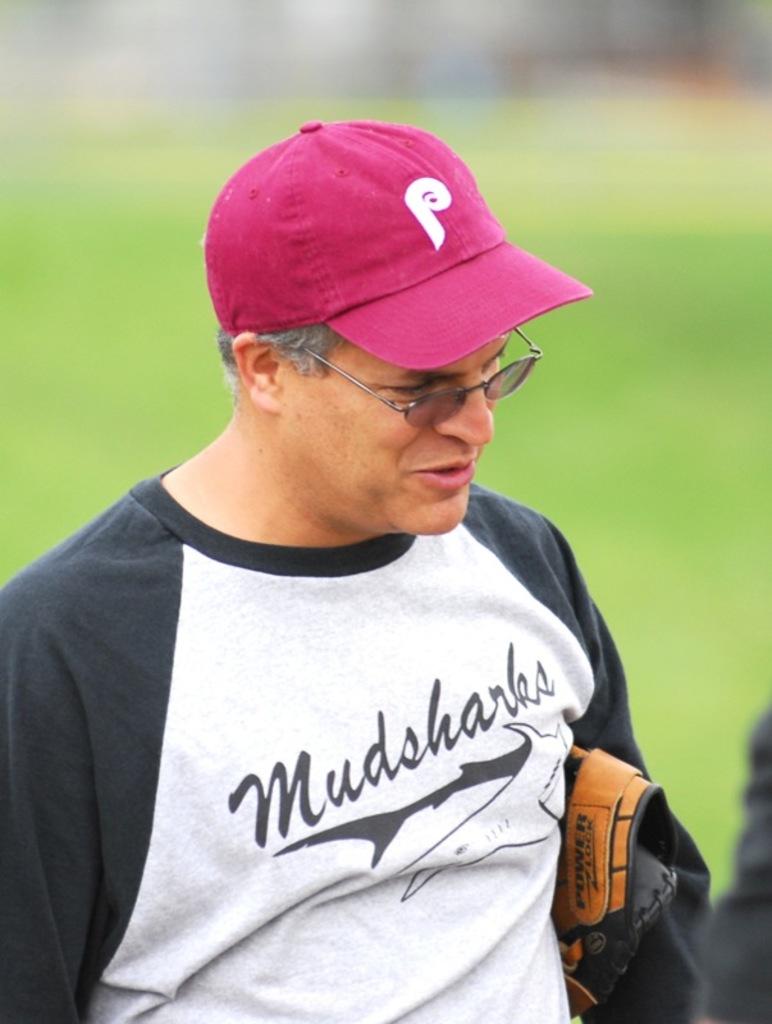What letter is on his hat?
Keep it short and to the point. P. 